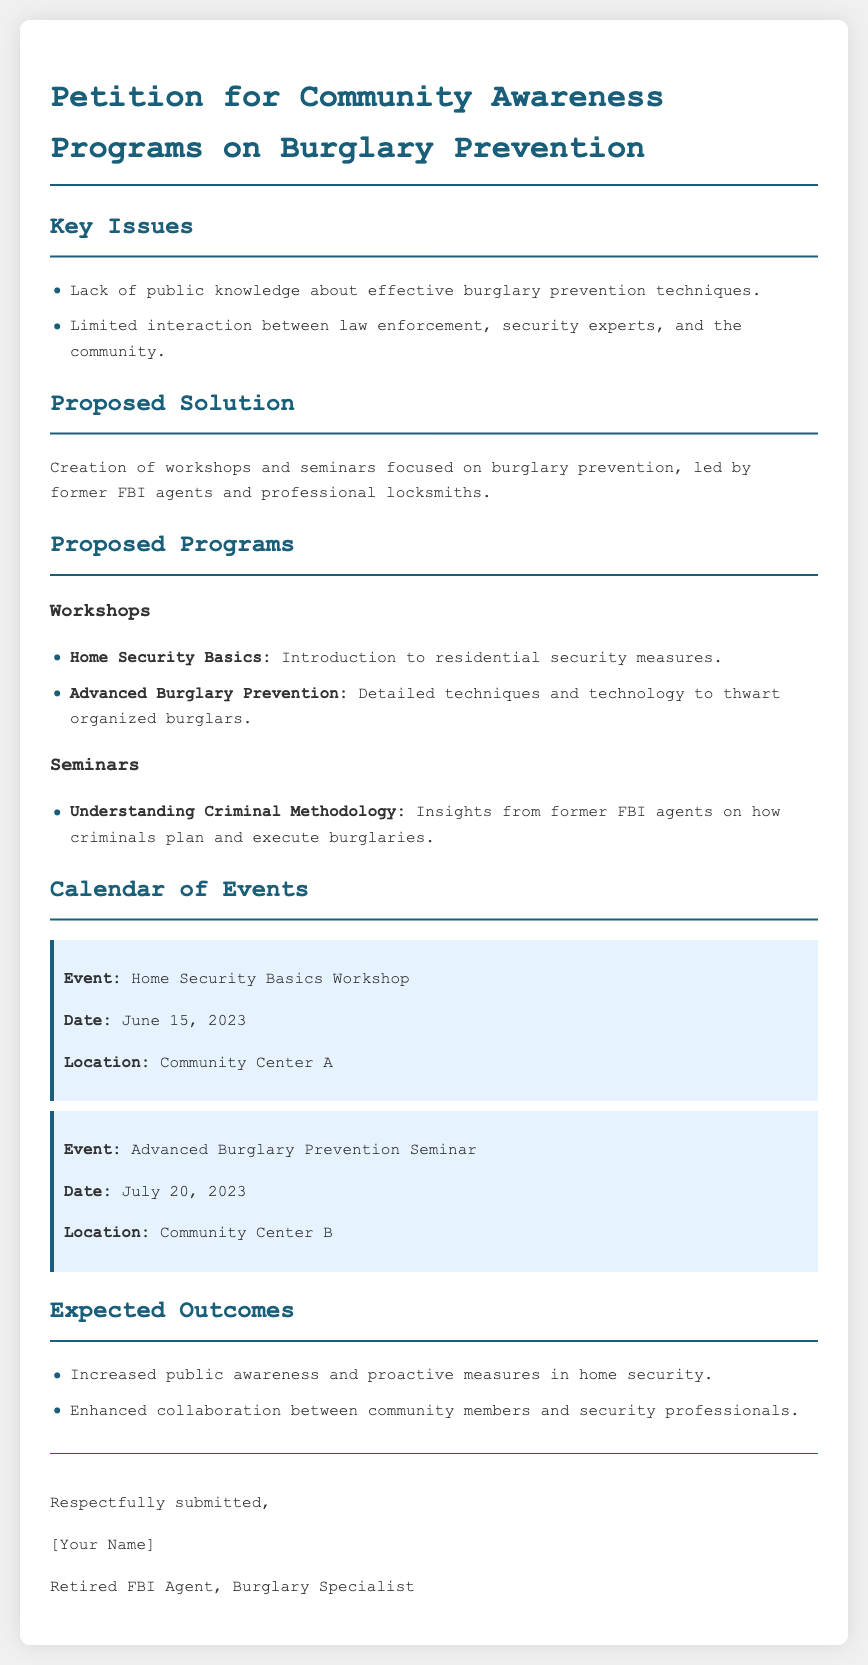What are the key issues identified in the petition? The petition identifies two key issues: lack of public knowledge about effective burglary prevention techniques and limited interaction between law enforcement, security experts, and the community.
Answer: Lack of public knowledge, Limited interaction What is the proposed solution in the document? The document suggests the creation of workshops and seminars focused on burglary prevention, led by former FBI agents and professional locksmiths.
Answer: Creation of workshops and seminars What is the location of the first event mentioned? The first event, Home Security Basics Workshop, is scheduled to take place at Community Center A.
Answer: Community Center A How many programs are listed in the proposed programs section? The proposed programs include two workshops and one seminar, making a total of three programs.
Answer: Three programs What is the date of the Advanced Burglary Prevention Seminar? The Advanced Burglary Prevention Seminar is scheduled for July 20, 2023.
Answer: July 20, 2023 What are the expected outcomes mentioned in the petition? The petition outlines two expected outcomes: increased public awareness and proactive measures in home security, and enhanced collaboration between community members and security professionals.
Answer: Increased public awareness, Enhanced collaboration Who submitted the petition? The document indicates that the petition is respectfully submitted by a retired FBI agent who specializes in burglary.
Answer: Retired FBI Agent, Burglary Specialist What type of event is scheduled on June 15, 2023? The document specifics that the event scheduled for June 15, 2023, is a workshop focused on home security basics.
Answer: Home Security Basics Workshop 